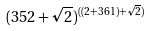Convert formula to latex. <formula><loc_0><loc_0><loc_500><loc_500>( 3 5 2 + \sqrt { 2 } ) ^ { ( ( 2 + 3 6 1 ) + \sqrt { 2 } ) }</formula> 